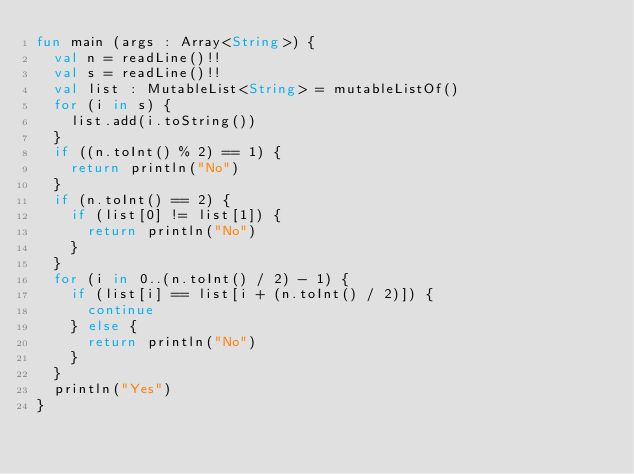Convert code to text. <code><loc_0><loc_0><loc_500><loc_500><_Kotlin_>fun main (args : Array<String>) {
	val n = readLine()!!
	val s = readLine()!!
	val list : MutableList<String> = mutableListOf()
	for (i in s) {
		list.add(i.toString())
	}
	if ((n.toInt() % 2) == 1) {
		return println("No")
	}
	if (n.toInt() == 2) {
		if (list[0] != list[1]) {
			return println("No")
		}
	}
	for (i in 0..(n.toInt() / 2) - 1) {
		if (list[i] == list[i + (n.toInt() / 2)]) {
			continue
		} else {
			return println("No")
		}
	}
	println("Yes")
}</code> 